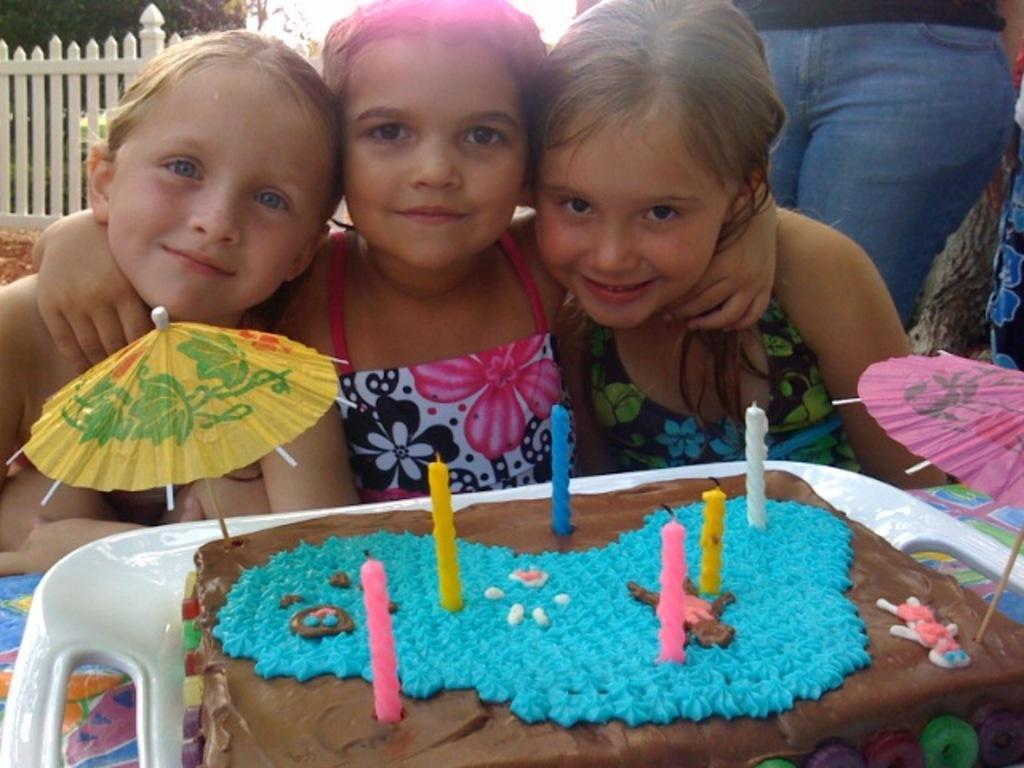Describe this image in one or two sentences. In the foreground of this picture, there is a cake in a platter on which few candles and umbrellas on it. In the background, there are three girls having smile on their faces and there is a person on the right top corner. In the background, we can see railing and trees. 